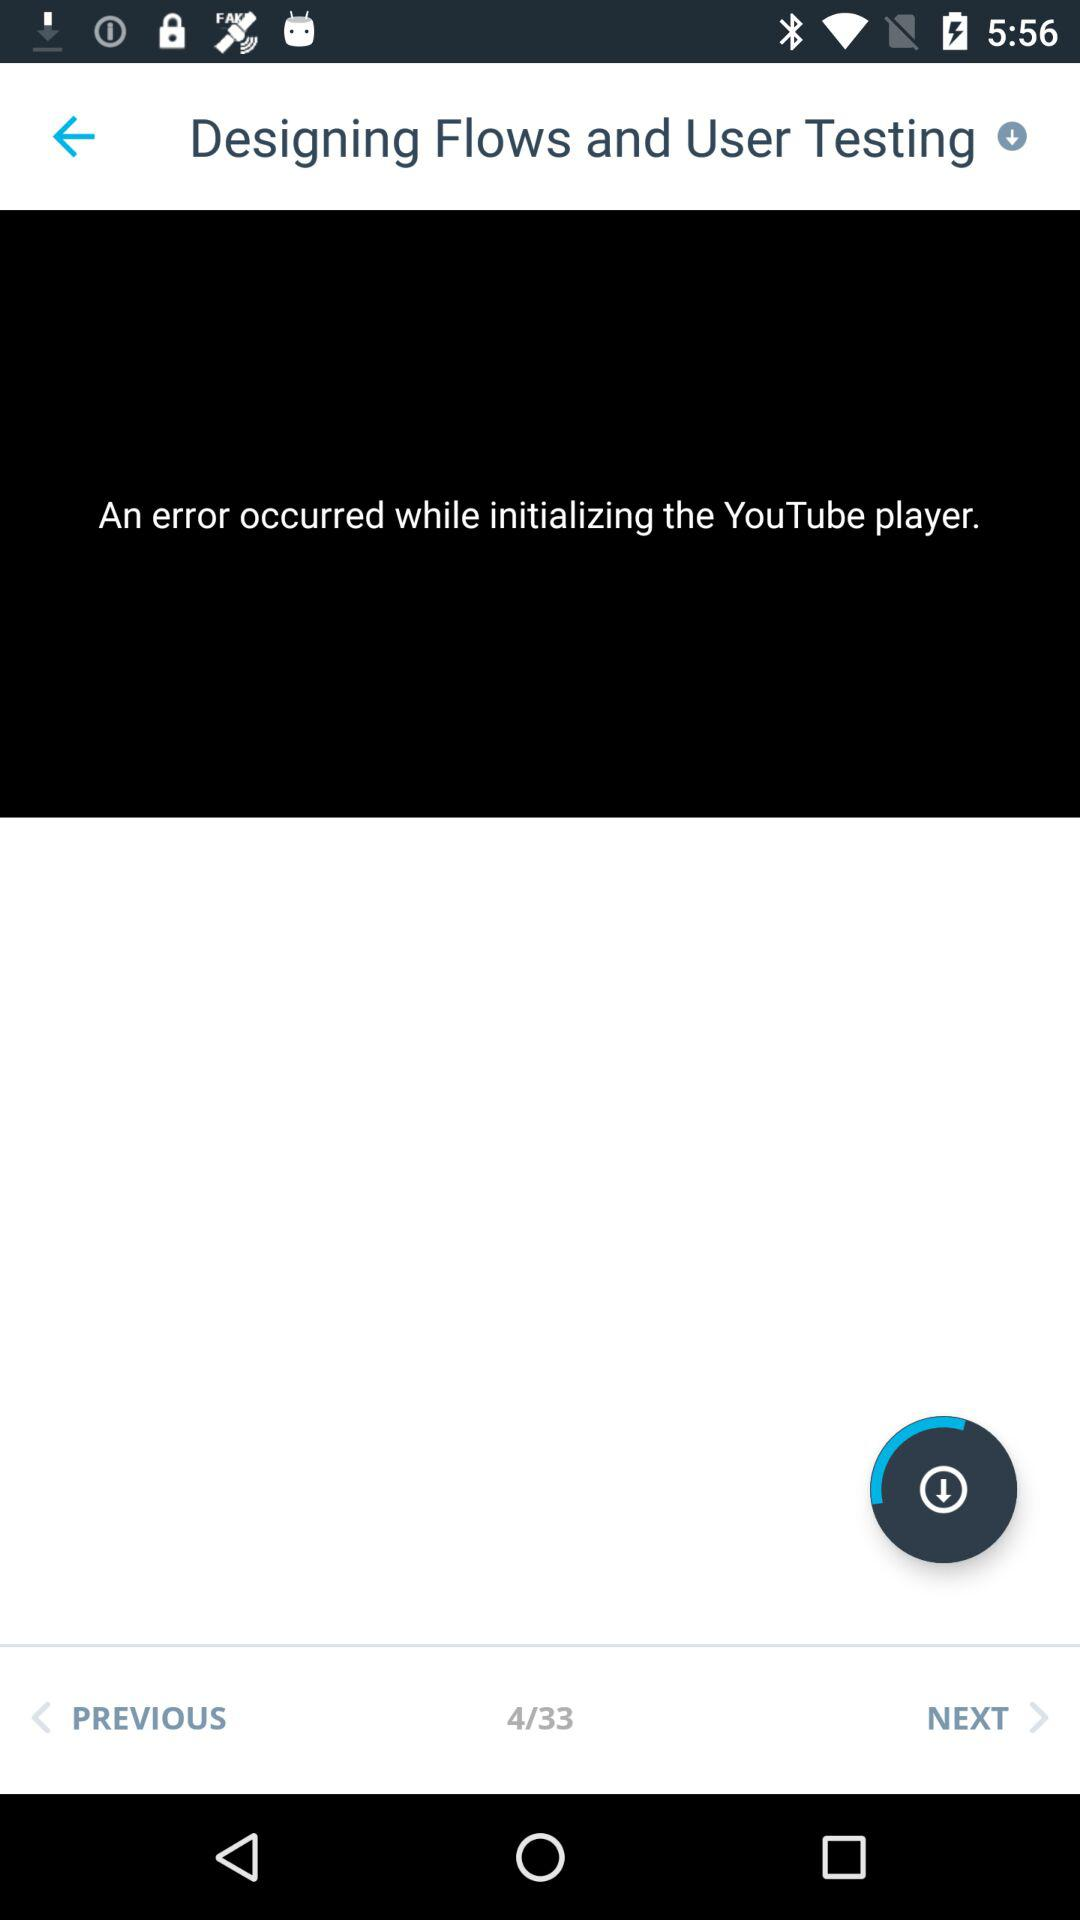What is the name of the application?
When the provided information is insufficient, respond with <no answer>. <no answer> 